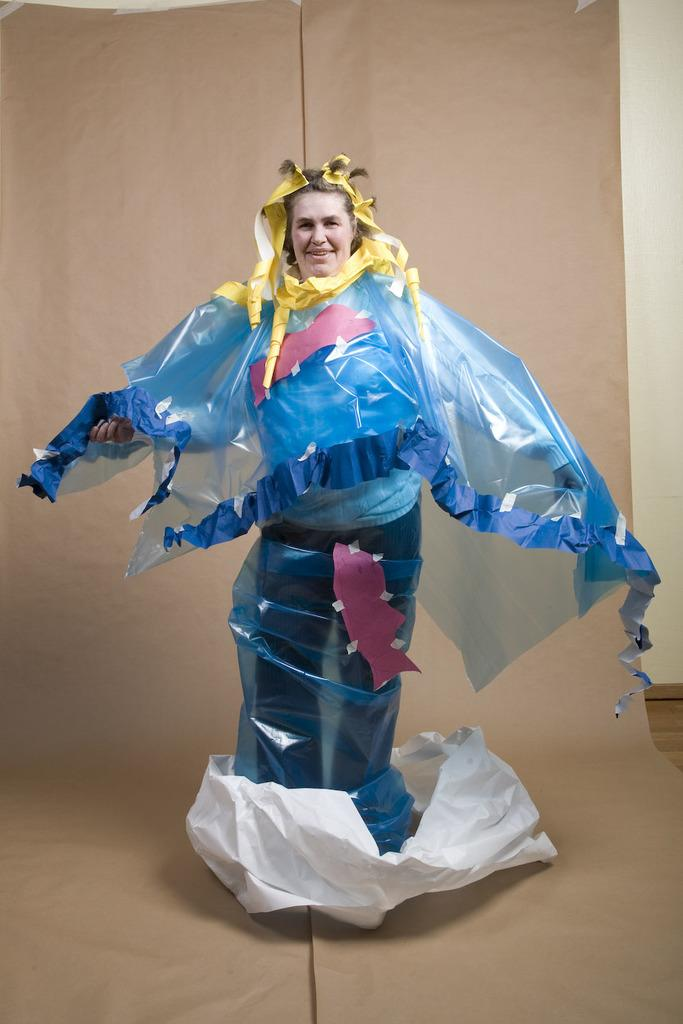What is the main subject of the image? There is a person standing on the cover. What can be seen at the bottom of the image? There is a mat on the floor at the bottom of the image. What is visible in the background of the image? There is a wall in the background of the image. What shape is the card that the person is holding in the image? There is no card present in the image, so it is not possible to determine its shape. 